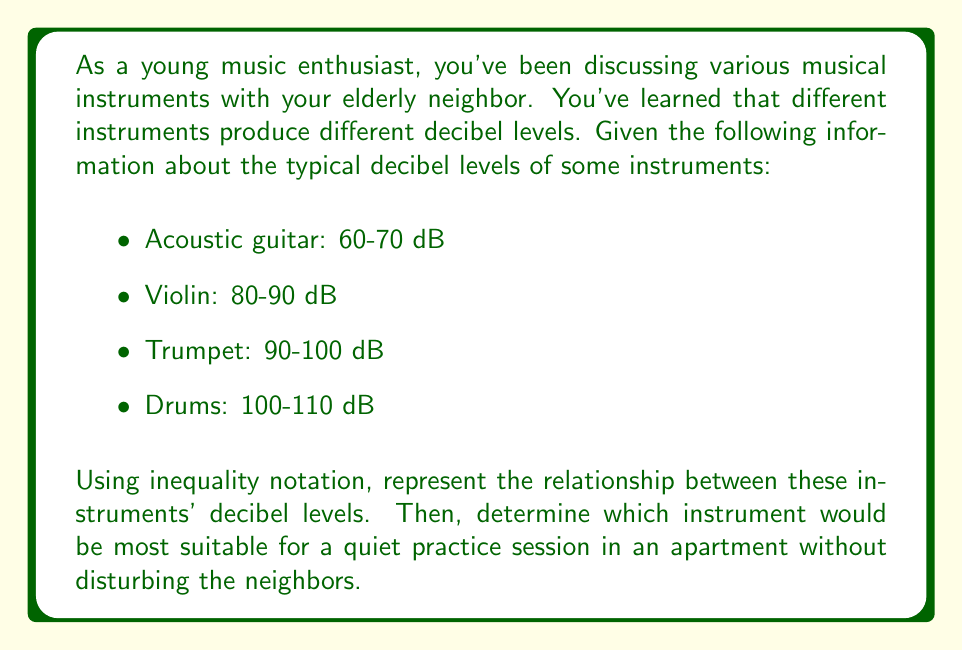Solve this math problem. Let's approach this step-by-step:

1) First, we need to represent the decibel levels using inequality notation. Let's use the following variables:
   $G$ for acoustic guitar
   $V$ for violin
   $T$ for trumpet
   $D$ for drums

2) We can represent the decibel ranges as follows:
   $$60 \leq G \leq 70$$
   $$80 \leq V \leq 90$$
   $$90 \leq T \leq 100$$
   $$100 \leq D \leq 110$$

3) Now, we can represent the relationship between these instruments:
   $$G < V < T < D$$

   This inequality shows that the acoustic guitar is quieter than the violin, which is quieter than the trumpet, which is quieter than the drums.

4) To determine which instrument is most suitable for quiet practice, we need to consider the lower end of each instrument's decibel range:
   
   Acoustic guitar: 60 dB
   Violin: 80 dB
   Trumpet: 90 dB
   Drums: 100 dB

5) The instrument with the lowest minimum decibel level would be the most suitable for quiet practice. In this case, it's the acoustic guitar at 60 dB.
Answer: The relationship between the instruments' decibel levels can be represented as:

$$G < V < T < D$$

where $G$, $V$, $T$, and $D$ represent the acoustic guitar, violin, trumpet, and drums respectively.

The acoustic guitar, with a minimum decibel level of 60 dB, would be the most suitable instrument for quiet practice in an apartment without disturbing the neighbors. 